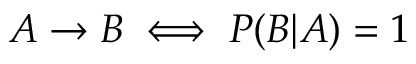<formula> <loc_0><loc_0><loc_500><loc_500>A \to B \iff P ( B | A ) = 1</formula> 